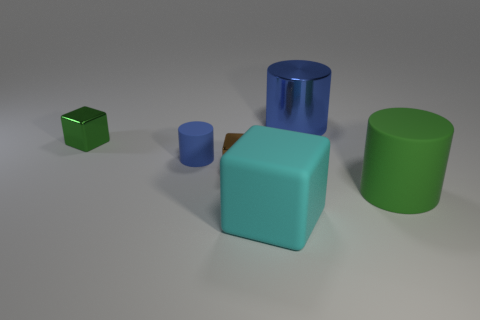Subtract all small cubes. How many cubes are left? 1 Add 4 small blue rubber cylinders. How many objects exist? 10 Subtract all green blocks. How many blocks are left? 2 Subtract 1 blocks. How many blocks are left? 2 Subtract all yellow cubes. Subtract all gray spheres. How many cubes are left? 3 Subtract all brown cubes. How many blue cylinders are left? 2 Subtract all tiny purple rubber things. Subtract all small green metallic objects. How many objects are left? 5 Add 3 blue cylinders. How many blue cylinders are left? 5 Add 3 big objects. How many big objects exist? 6 Subtract 0 red cylinders. How many objects are left? 6 